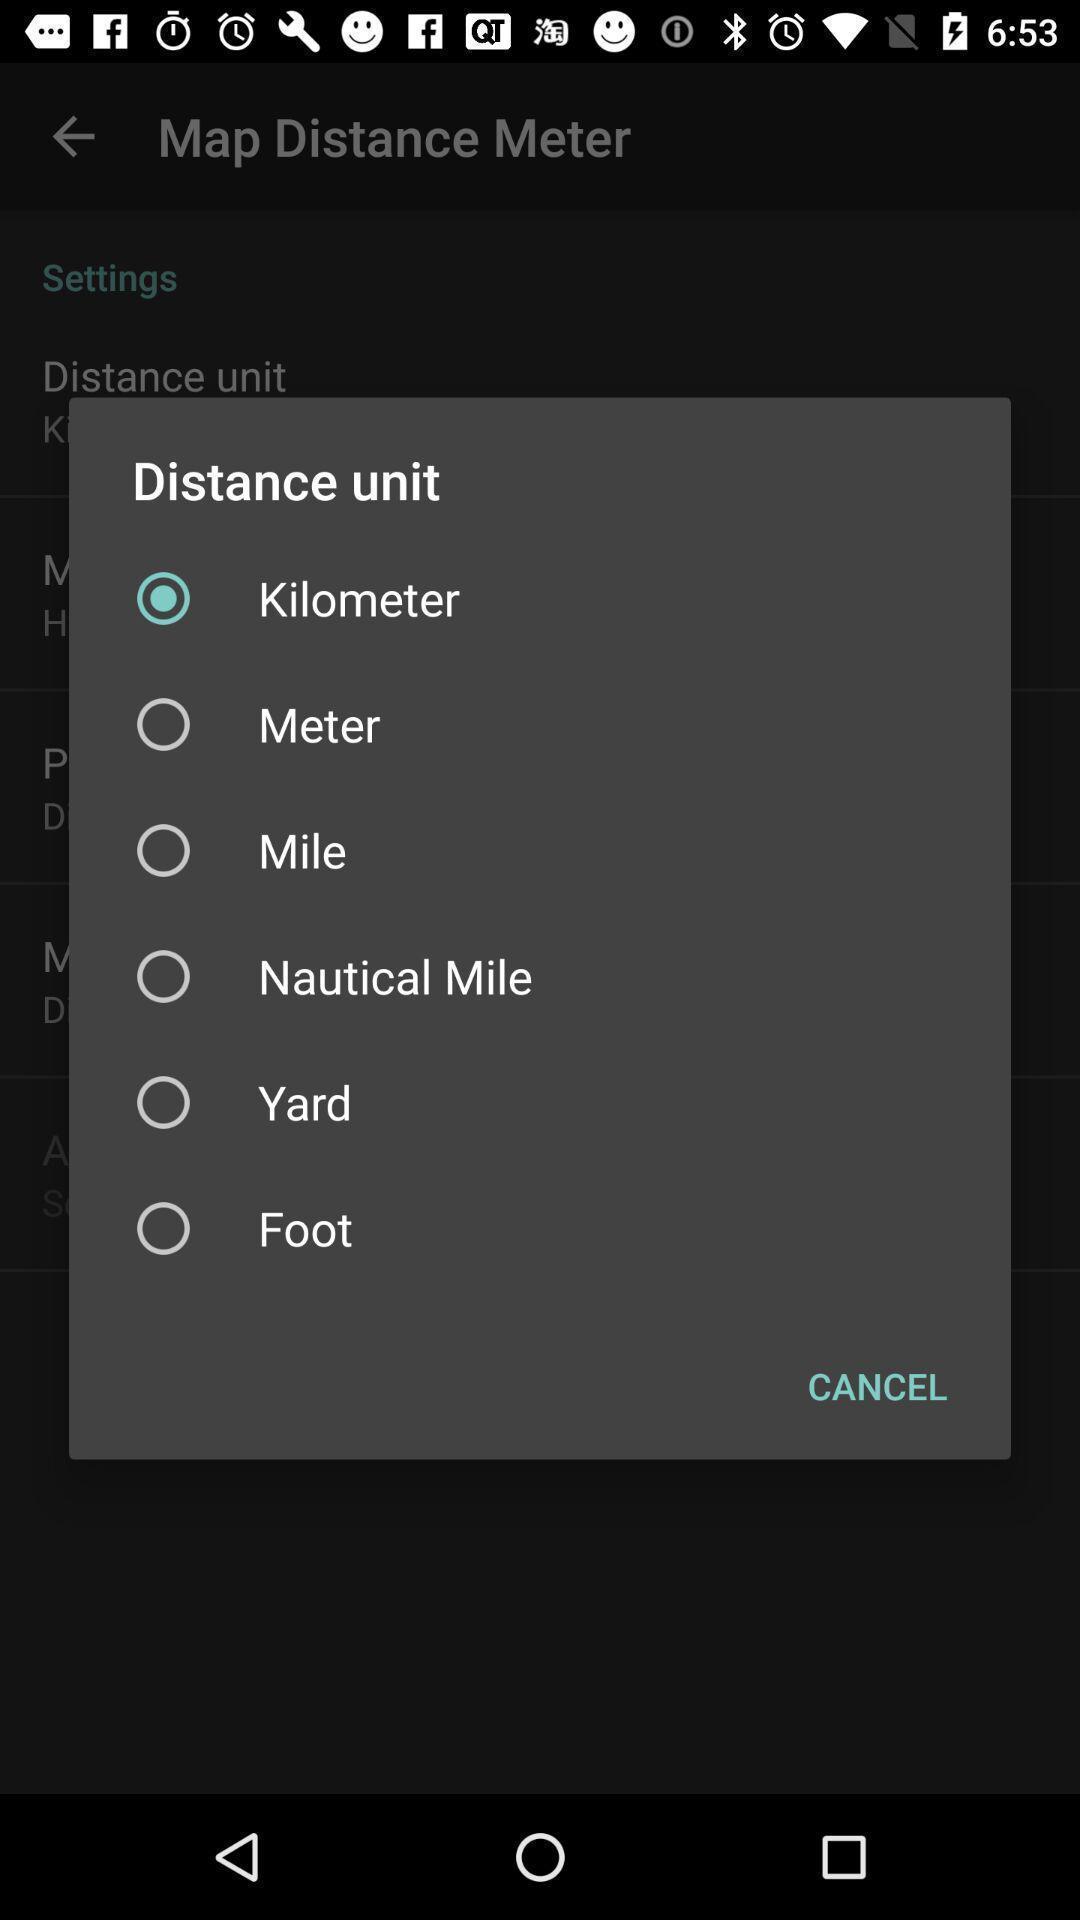Provide a detailed account of this screenshot. Pop-up showing the list of distance measurement units. 